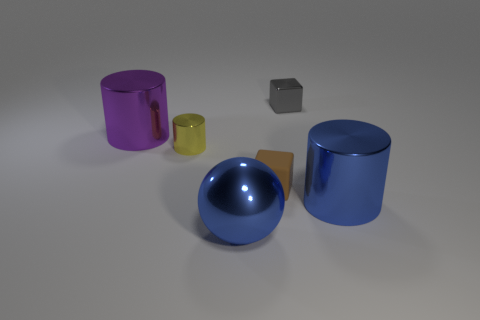Add 1 large blue metal objects. How many objects exist? 7 Subtract all blocks. How many objects are left? 4 Subtract 0 cyan cubes. How many objects are left? 6 Subtract all metallic spheres. Subtract all large blue blocks. How many objects are left? 5 Add 4 big purple metallic objects. How many big purple metallic objects are left? 5 Add 5 large blue things. How many large blue things exist? 7 